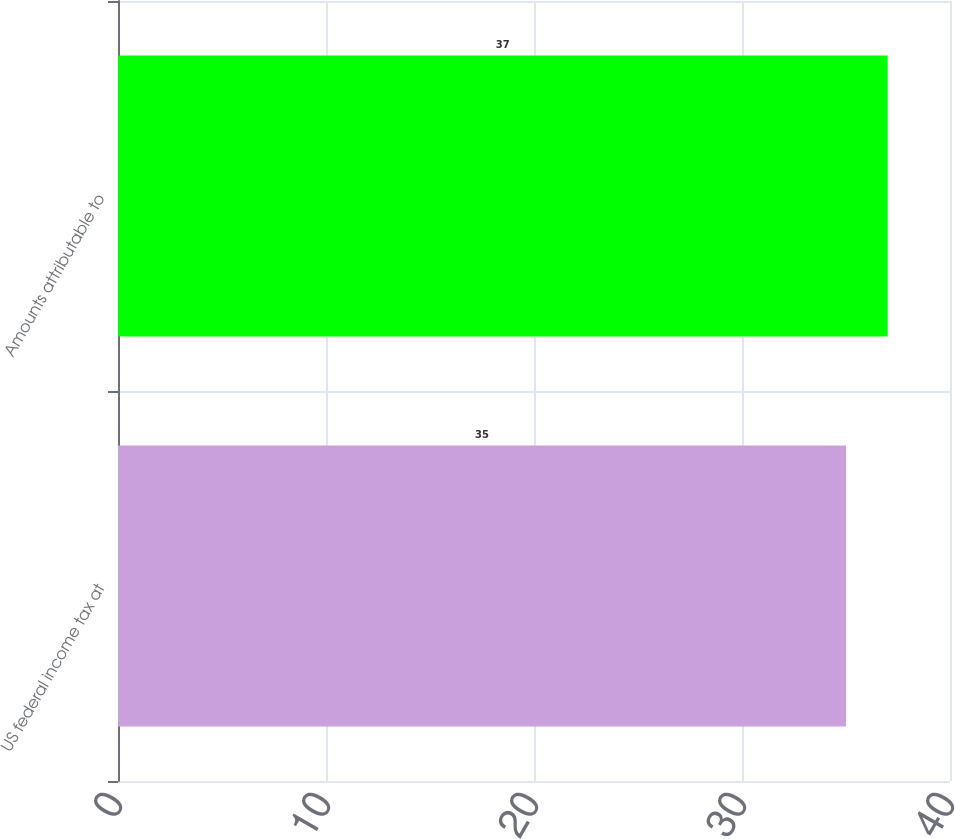Convert chart to OTSL. <chart><loc_0><loc_0><loc_500><loc_500><bar_chart><fcel>US federal income tax at<fcel>Amounts attributable to<nl><fcel>35<fcel>37<nl></chart> 